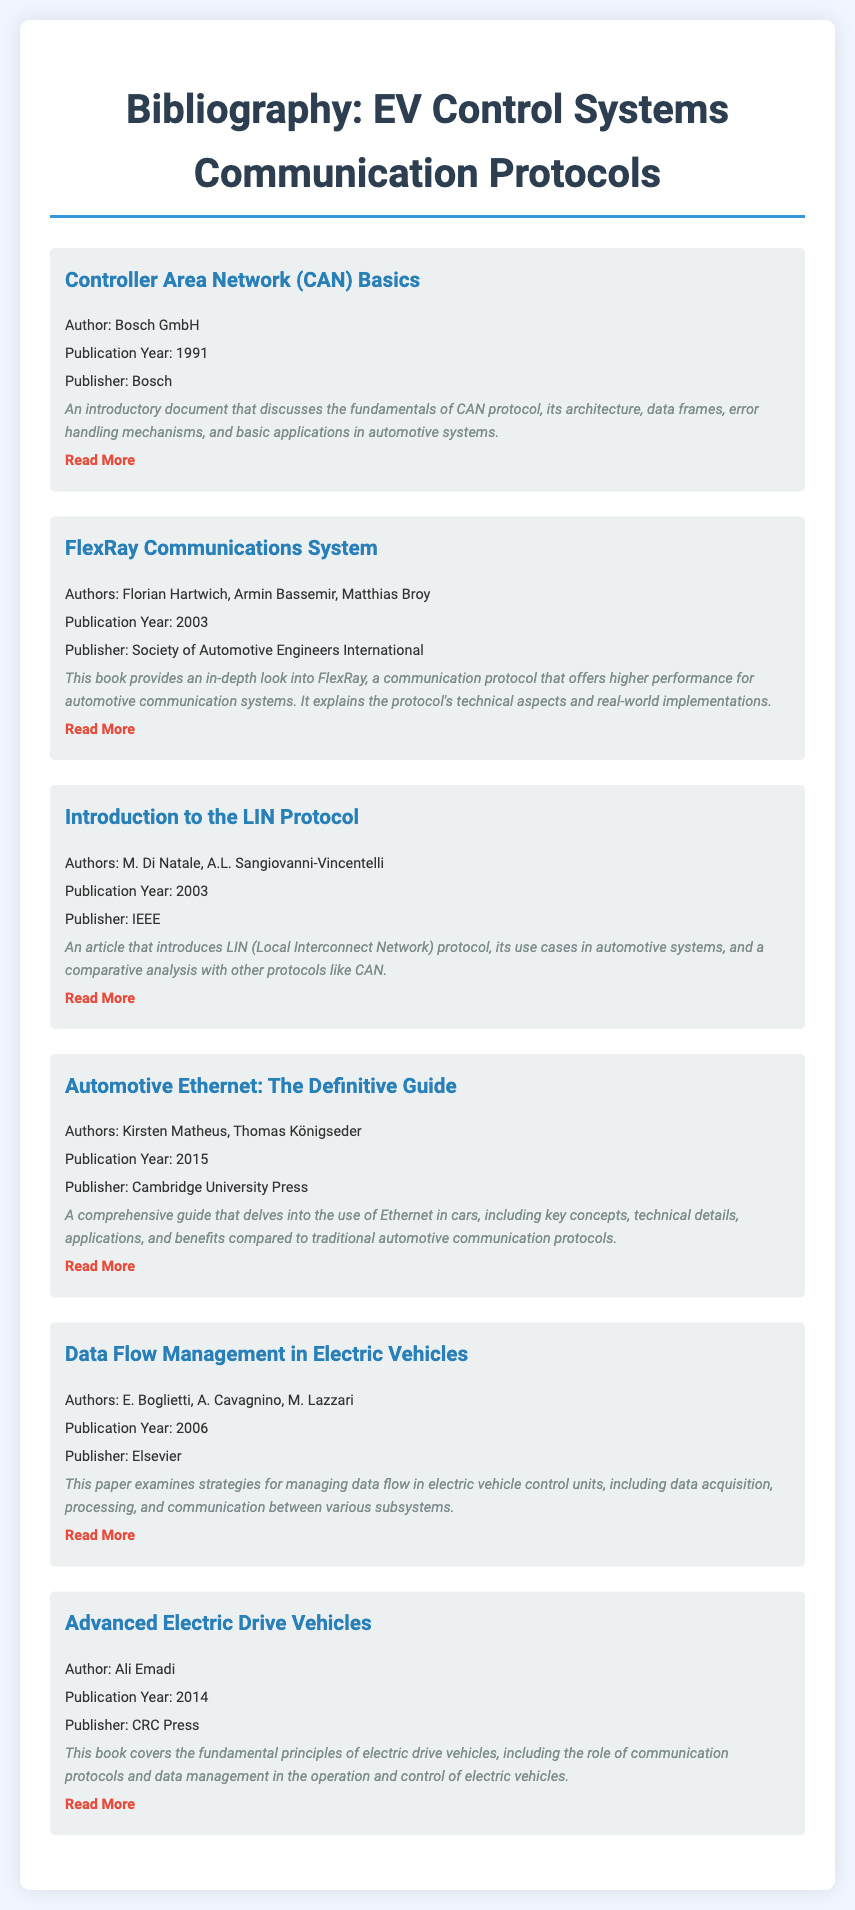What is the publication year of the CAN Basics document? The publication year is explicitly stated in the entry for "Controller Area Network (CAN) Basics."
Answer: 1991 Who are the authors of the "Introduction to the LIN Protocol"? The authors are specified in the entry for "Introduction to the LIN Protocol."
Answer: M. Di Natale, A.L. Sangiovanni-Vincentelli What is the title of the paper published in 2006? The title is obtained from the entry that includes the publication year 2006.
Answer: Data Flow Management in Electric Vehicles Which publisher released "Automotive Ethernet: The Definitive Guide"? The publisher is clearly mentioned in the entry for "Automotive Ethernet: The Definitive Guide."
Answer: Cambridge University Press What major topic does the book "Advanced Electric Drive Vehicles" cover? The major topic is inferred from the description provided in the entry for "Advanced Electric Drive Vehicles."
Answer: Communication protocols and data management Which communication protocol is mentioned multiple times in the document? The protocol can be found in several entries, indicating its importance in electric vehicle control systems.
Answer: CAN What design characteristic is noted in the entries for formatting? The formatting feature common to all entries is highlighted in their descriptions and styling elements.
Answer: Transition effect on hover What type of document is this collection? The purpose of the collection is stated in the title and context of the entries provided.
Answer: Bibliography 